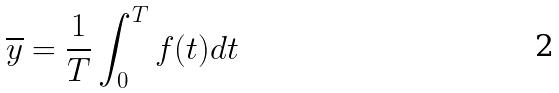<formula> <loc_0><loc_0><loc_500><loc_500>\overline { y } = \frac { 1 } { T } \int _ { 0 } ^ { T } f ( t ) d t</formula> 